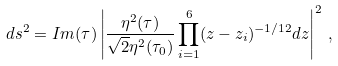<formula> <loc_0><loc_0><loc_500><loc_500>d s ^ { 2 } = I m ( \tau ) \left | \frac { \eta ^ { 2 } ( \tau ) } { \sqrt { 2 } \eta ^ { 2 } ( \tau _ { 0 } ) } \prod _ { i = 1 } ^ { 6 } ( z - z _ { i } ) ^ { - 1 / 1 2 } d z \right | ^ { 2 } \, ,</formula> 